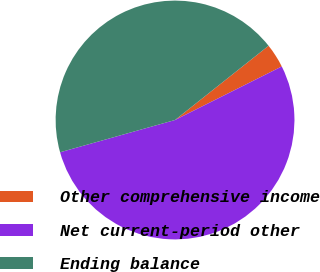Convert chart. <chart><loc_0><loc_0><loc_500><loc_500><pie_chart><fcel>Other comprehensive income<fcel>Net current-period other<fcel>Ending balance<nl><fcel>3.28%<fcel>53.04%<fcel>43.68%<nl></chart> 